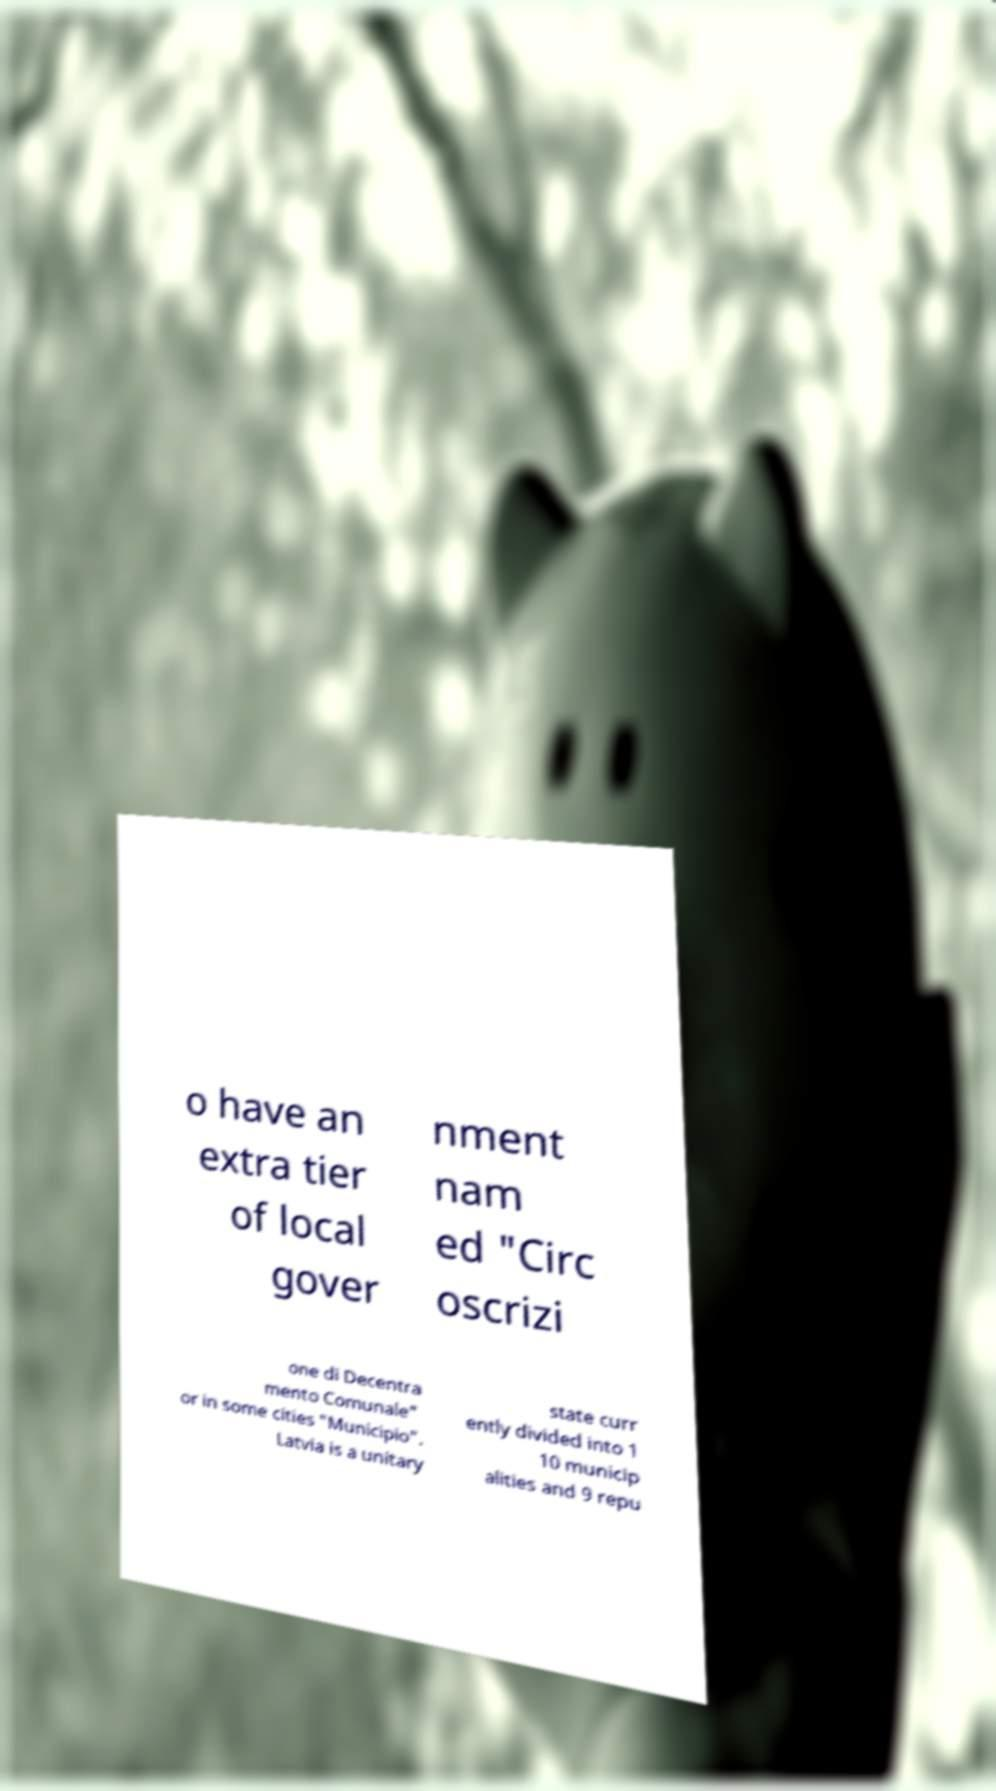Please identify and transcribe the text found in this image. o have an extra tier of local gover nment nam ed "Circ oscrizi one di Decentra mento Comunale" or in some cities "Municipio". Latvia is a unitary state curr ently divided into 1 10 municip alities and 9 repu 